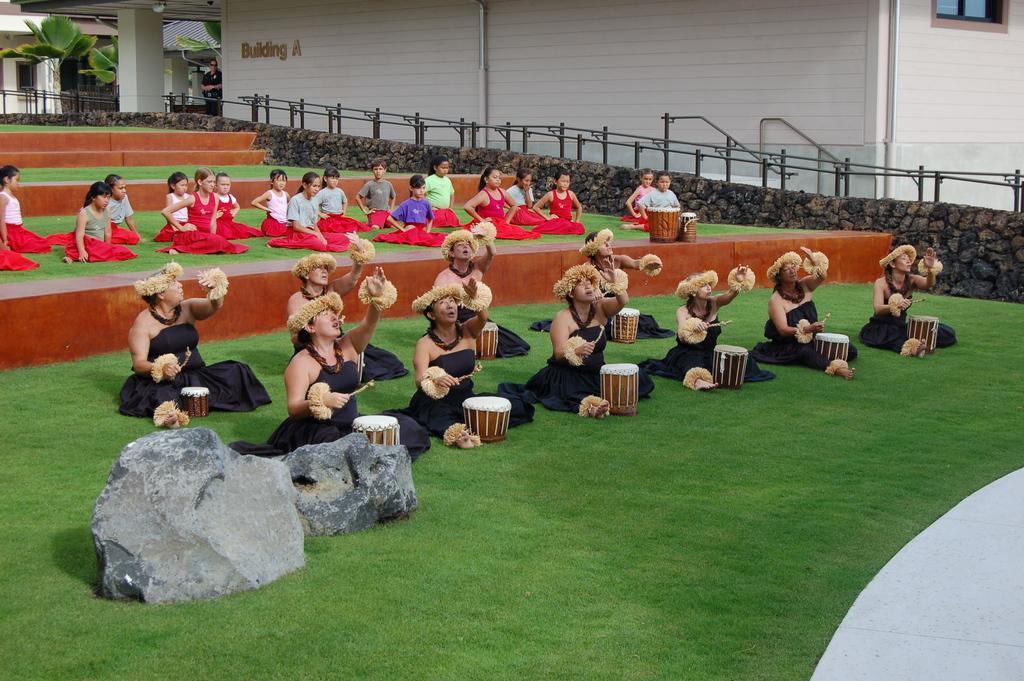How would you summarize this image in a sentence or two? In the foreground of this image, there are women sitting on the grass and playing musical instruments. In the background, there are girls sitting on the grass. We can also see rocks, railing, building, trees and a pillar. 